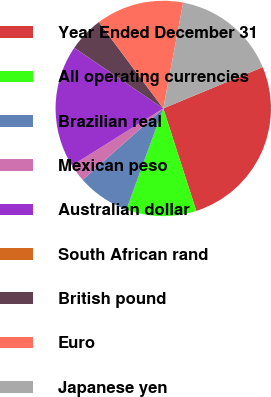<chart> <loc_0><loc_0><loc_500><loc_500><pie_chart><fcel>Year Ended December 31<fcel>All operating currencies<fcel>Brazilian real<fcel>Mexican peso<fcel>Australian dollar<fcel>South African rand<fcel>British pound<fcel>Euro<fcel>Japanese yen<nl><fcel>26.3%<fcel>10.53%<fcel>7.9%<fcel>2.64%<fcel>18.41%<fcel>0.01%<fcel>5.27%<fcel>13.16%<fcel>15.78%<nl></chart> 